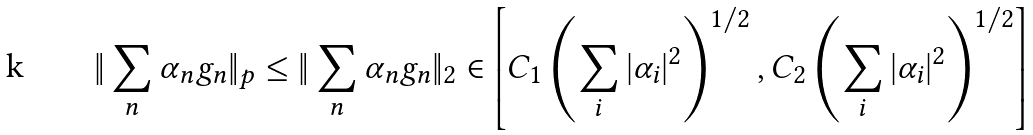<formula> <loc_0><loc_0><loc_500><loc_500>\| \sum _ { n } \alpha _ { n } g _ { n } \| _ { p } \leq \| \sum _ { n } \alpha _ { n } g _ { n } \| _ { 2 } \in \left [ C _ { 1 } \left ( \sum _ { i } | \alpha _ { i } | ^ { 2 } \right ) ^ { 1 / 2 } , C _ { 2 } \left ( \sum _ { i } | \alpha _ { i } | ^ { 2 } \right ) ^ { 1 / 2 } \right ]</formula> 